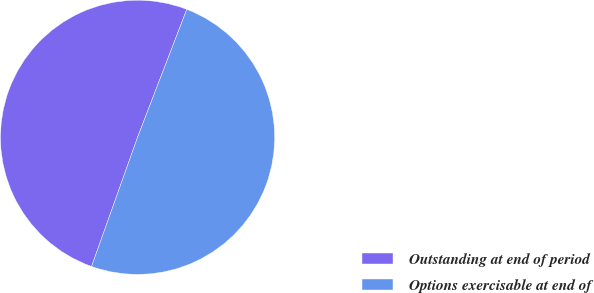Convert chart to OTSL. <chart><loc_0><loc_0><loc_500><loc_500><pie_chart><fcel>Outstanding at end of period<fcel>Options exercisable at end of<nl><fcel>50.4%<fcel>49.6%<nl></chart> 